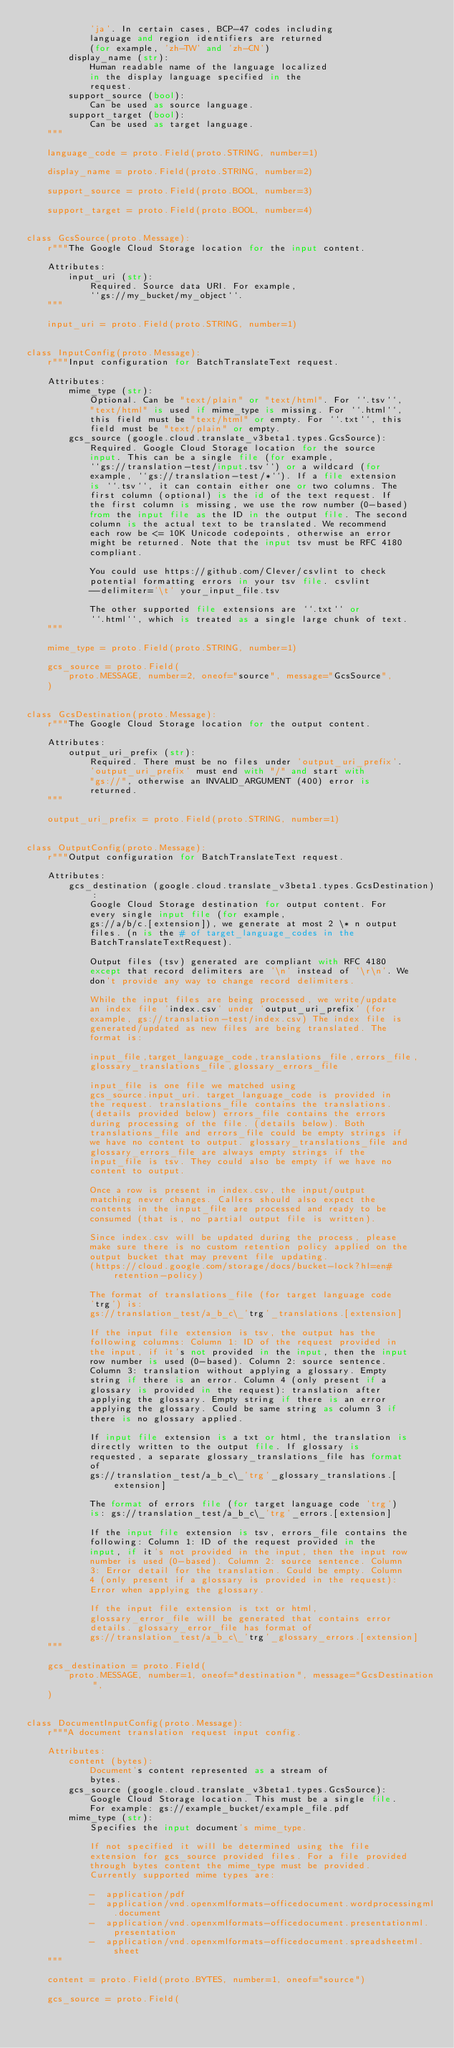Convert code to text. <code><loc_0><loc_0><loc_500><loc_500><_Python_>            'ja'. In certain cases, BCP-47 codes including
            language and region identifiers are returned
            (for example, 'zh-TW' and 'zh-CN')
        display_name (str):
            Human readable name of the language localized
            in the display language specified in the
            request.
        support_source (bool):
            Can be used as source language.
        support_target (bool):
            Can be used as target language.
    """

    language_code = proto.Field(proto.STRING, number=1)

    display_name = proto.Field(proto.STRING, number=2)

    support_source = proto.Field(proto.BOOL, number=3)

    support_target = proto.Field(proto.BOOL, number=4)


class GcsSource(proto.Message):
    r"""The Google Cloud Storage location for the input content.

    Attributes:
        input_uri (str):
            Required. Source data URI. For example,
            ``gs://my_bucket/my_object``.
    """

    input_uri = proto.Field(proto.STRING, number=1)


class InputConfig(proto.Message):
    r"""Input configuration for BatchTranslateText request.

    Attributes:
        mime_type (str):
            Optional. Can be "text/plain" or "text/html". For ``.tsv``,
            "text/html" is used if mime_type is missing. For ``.html``,
            this field must be "text/html" or empty. For ``.txt``, this
            field must be "text/plain" or empty.
        gcs_source (google.cloud.translate_v3beta1.types.GcsSource):
            Required. Google Cloud Storage location for the source
            input. This can be a single file (for example,
            ``gs://translation-test/input.tsv``) or a wildcard (for
            example, ``gs://translation-test/*``). If a file extension
            is ``.tsv``, it can contain either one or two columns. The
            first column (optional) is the id of the text request. If
            the first column is missing, we use the row number (0-based)
            from the input file as the ID in the output file. The second
            column is the actual text to be translated. We recommend
            each row be <= 10K Unicode codepoints, otherwise an error
            might be returned. Note that the input tsv must be RFC 4180
            compliant.

            You could use https://github.com/Clever/csvlint to check
            potential formatting errors in your tsv file. csvlint
            --delimiter='\t' your_input_file.tsv

            The other supported file extensions are ``.txt`` or
            ``.html``, which is treated as a single large chunk of text.
    """

    mime_type = proto.Field(proto.STRING, number=1)

    gcs_source = proto.Field(
        proto.MESSAGE, number=2, oneof="source", message="GcsSource",
    )


class GcsDestination(proto.Message):
    r"""The Google Cloud Storage location for the output content.

    Attributes:
        output_uri_prefix (str):
            Required. There must be no files under 'output_uri_prefix'.
            'output_uri_prefix' must end with "/" and start with
            "gs://", otherwise an INVALID_ARGUMENT (400) error is
            returned.
    """

    output_uri_prefix = proto.Field(proto.STRING, number=1)


class OutputConfig(proto.Message):
    r"""Output configuration for BatchTranslateText request.

    Attributes:
        gcs_destination (google.cloud.translate_v3beta1.types.GcsDestination):
            Google Cloud Storage destination for output content. For
            every single input file (for example,
            gs://a/b/c.[extension]), we generate at most 2 \* n output
            files. (n is the # of target_language_codes in the
            BatchTranslateTextRequest).

            Output files (tsv) generated are compliant with RFC 4180
            except that record delimiters are '\n' instead of '\r\n'. We
            don't provide any way to change record delimiters.

            While the input files are being processed, we write/update
            an index file 'index.csv' under 'output_uri_prefix' (for
            example, gs://translation-test/index.csv) The index file is
            generated/updated as new files are being translated. The
            format is:

            input_file,target_language_code,translations_file,errors_file,
            glossary_translations_file,glossary_errors_file

            input_file is one file we matched using
            gcs_source.input_uri. target_language_code is provided in
            the request. translations_file contains the translations.
            (details provided below) errors_file contains the errors
            during processing of the file. (details below). Both
            translations_file and errors_file could be empty strings if
            we have no content to output. glossary_translations_file and
            glossary_errors_file are always empty strings if the
            input_file is tsv. They could also be empty if we have no
            content to output.

            Once a row is present in index.csv, the input/output
            matching never changes. Callers should also expect the
            contents in the input_file are processed and ready to be
            consumed (that is, no partial output file is written).

            Since index.csv will be updated during the process, please
            make sure there is no custom retention policy applied on the
            output bucket that may prevent file updating.
            (https://cloud.google.com/storage/docs/bucket-lock?hl=en#retention-policy)

            The format of translations_file (for target language code
            'trg') is:
            gs://translation_test/a_b_c\_'trg'_translations.[extension]

            If the input file extension is tsv, the output has the
            following columns: Column 1: ID of the request provided in
            the input, if it's not provided in the input, then the input
            row number is used (0-based). Column 2: source sentence.
            Column 3: translation without applying a glossary. Empty
            string if there is an error. Column 4 (only present if a
            glossary is provided in the request): translation after
            applying the glossary. Empty string if there is an error
            applying the glossary. Could be same string as column 3 if
            there is no glossary applied.

            If input file extension is a txt or html, the translation is
            directly written to the output file. If glossary is
            requested, a separate glossary_translations_file has format
            of
            gs://translation_test/a_b_c\_'trg'_glossary_translations.[extension]

            The format of errors file (for target language code 'trg')
            is: gs://translation_test/a_b_c\_'trg'_errors.[extension]

            If the input file extension is tsv, errors_file contains the
            following: Column 1: ID of the request provided in the
            input, if it's not provided in the input, then the input row
            number is used (0-based). Column 2: source sentence. Column
            3: Error detail for the translation. Could be empty. Column
            4 (only present if a glossary is provided in the request):
            Error when applying the glossary.

            If the input file extension is txt or html,
            glossary_error_file will be generated that contains error
            details. glossary_error_file has format of
            gs://translation_test/a_b_c\_'trg'_glossary_errors.[extension]
    """

    gcs_destination = proto.Field(
        proto.MESSAGE, number=1, oneof="destination", message="GcsDestination",
    )


class DocumentInputConfig(proto.Message):
    r"""A document translation request input config.

    Attributes:
        content (bytes):
            Document's content represented as a stream of
            bytes.
        gcs_source (google.cloud.translate_v3beta1.types.GcsSource):
            Google Cloud Storage location. This must be a single file.
            For example: gs://example_bucket/example_file.pdf
        mime_type (str):
            Specifies the input document's mime_type.

            If not specified it will be determined using the file
            extension for gcs_source provided files. For a file provided
            through bytes content the mime_type must be provided.
            Currently supported mime types are:

            -  application/pdf
            -  application/vnd.openxmlformats-officedocument.wordprocessingml.document
            -  application/vnd.openxmlformats-officedocument.presentationml.presentation
            -  application/vnd.openxmlformats-officedocument.spreadsheetml.sheet
    """

    content = proto.Field(proto.BYTES, number=1, oneof="source")

    gcs_source = proto.Field(</code> 